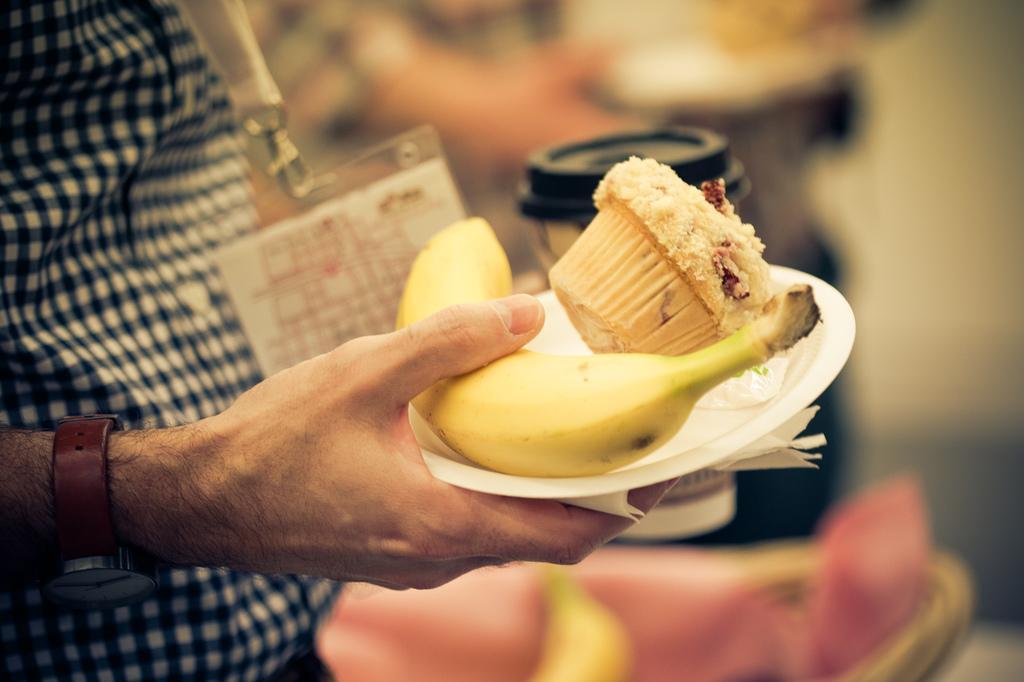Can you describe this image briefly? In this image we can see a person is holding some food items and he is wearing an identity card. 